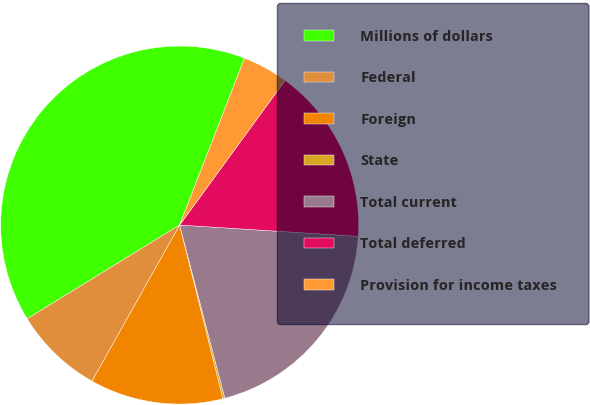<chart> <loc_0><loc_0><loc_500><loc_500><pie_chart><fcel>Millions of dollars<fcel>Federal<fcel>Foreign<fcel>State<fcel>Total current<fcel>Total deferred<fcel>Provision for income taxes<nl><fcel>39.68%<fcel>8.08%<fcel>12.03%<fcel>0.18%<fcel>19.93%<fcel>15.98%<fcel>4.13%<nl></chart> 